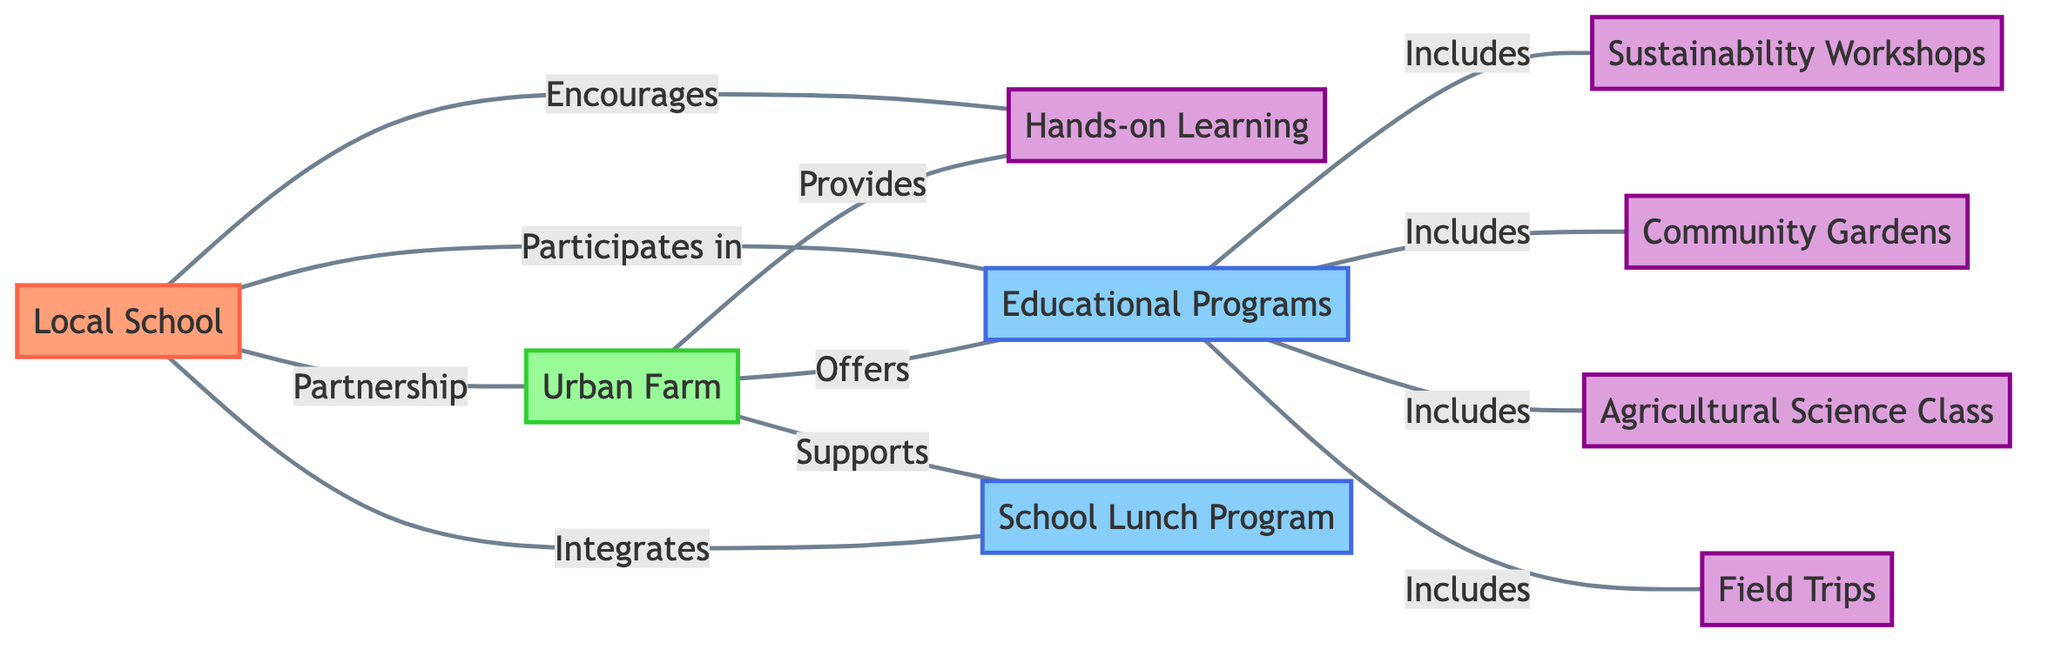What nodes are connected to the Local School? The Local School is connected to the Urban Farm, Hands-on Learning, Educational Programs, and School Lunch Program. By examining the edges originating from the Local School node, we can identify these connections.
Answer: Urban Farm, Hands-on Learning, Educational Programs, School Lunch Program How many nodes are in the diagram? The diagram contains a total of 10 nodes, as listed in the data input. This includes Local School, Urban Farm, Hands-on Learning, Educational Programs, Sustainability Workshops, Community Gardens, Agricultural Science Class, Field Trips, and School Lunch Program.
Answer: 10 What relationship connects Urban Farm and Educational Programs? The Urban Farm offers Educational Programs, as indicated by the edge connecting these two nodes labeled "Offers." We can identify this relationship by looking for the relevant edge in the diagram.
Answer: Offers Which activities are included in Educational Programs? The Educational Programs include Sustainability Workshops, Community Gardens, Agricultural Science Class, and Field Trips, as several edges point from Educational Programs to these activities. We can deduce this by counting the edges that include the label "Includes."
Answer: Sustainability Workshops, Community Gardens, Agricultural Science Class, Field Trips What support does Urban Farm provide? The Urban Farm supports the School Lunch Program, as indicated by the edge connecting these two nodes labeled "Supports." This relationship can be found by checking the connections from Urban Farm.
Answer: Supports What is the primary purpose of the connection between Local School and Urban Farm? The primary purpose is "Partnership," as reflected in the edge labeled "Partnership" that connects these two nodes. This relationship can be established by reviewing the specific edge linking Local School to Urban Farm.
Answer: Partnership How many edges are present in the diagram? The diagram contains 10 edges, as indicated in the provided data. Each edge represents a connection between two nodes, and we can count each connection listed in the edges section of the data.
Answer: 10 Which node represents hands-on learning? The node representing hands-on learning is labeled "Hands-on Learning." By scanning through the node identifiers in the provided data, we can quickly identify this specific node.
Answer: Hands-on Learning Which two nodes are directly linked by the label "Encourages"? The two nodes linked by the label "Encourages" are the Local School and Hands-on Learning, as specified by the edge connecting them. We find this relationship by looking for the edge with that specific label.
Answer: Local School and Hands-on Learning 